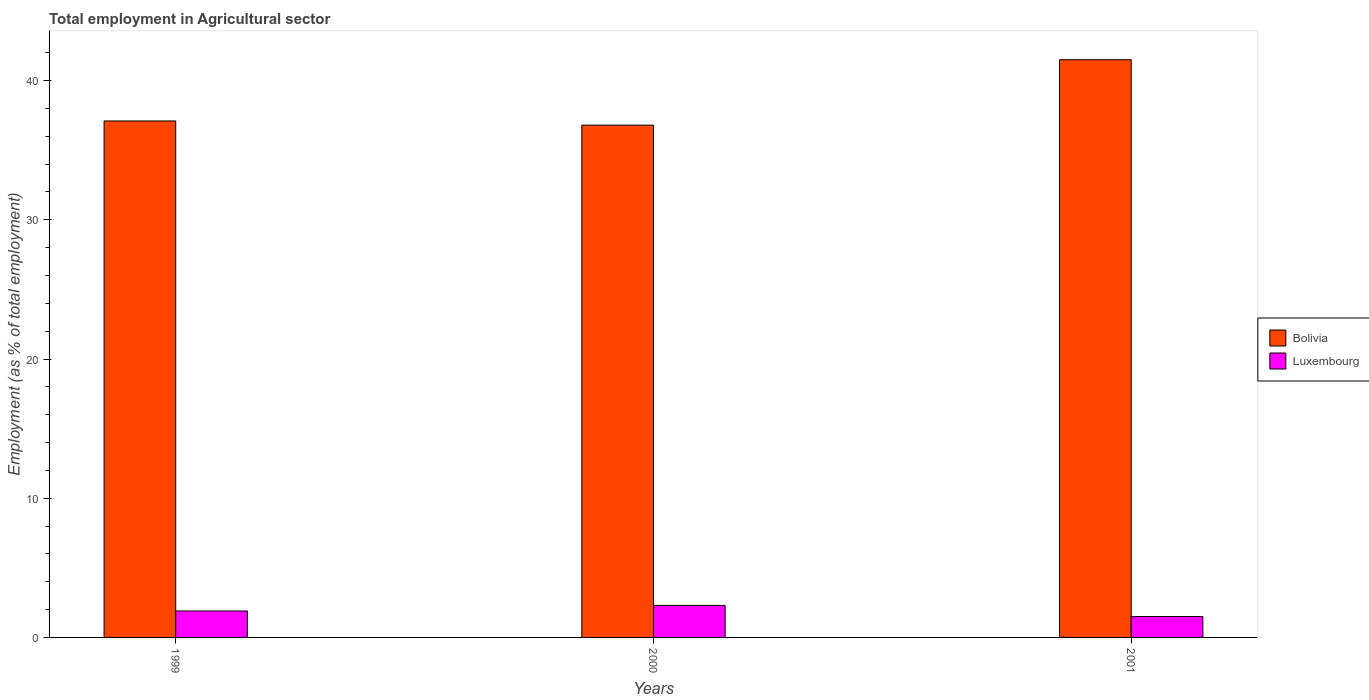How many groups of bars are there?
Your answer should be very brief. 3. Are the number of bars per tick equal to the number of legend labels?
Ensure brevity in your answer.  Yes. Are the number of bars on each tick of the X-axis equal?
Ensure brevity in your answer.  Yes. How many bars are there on the 2nd tick from the left?
Keep it short and to the point. 2. How many bars are there on the 1st tick from the right?
Keep it short and to the point. 2. What is the label of the 1st group of bars from the left?
Your answer should be very brief. 1999. What is the employment in agricultural sector in Bolivia in 1999?
Provide a succinct answer. 37.1. Across all years, what is the maximum employment in agricultural sector in Bolivia?
Provide a succinct answer. 41.5. In which year was the employment in agricultural sector in Luxembourg maximum?
Your response must be concise. 2000. In which year was the employment in agricultural sector in Bolivia minimum?
Provide a succinct answer. 2000. What is the total employment in agricultural sector in Bolivia in the graph?
Ensure brevity in your answer.  115.4. What is the difference between the employment in agricultural sector in Bolivia in 2000 and that in 2001?
Give a very brief answer. -4.7. What is the difference between the employment in agricultural sector in Luxembourg in 2001 and the employment in agricultural sector in Bolivia in 1999?
Keep it short and to the point. -35.6. What is the average employment in agricultural sector in Luxembourg per year?
Offer a very short reply. 1.9. In the year 2000, what is the difference between the employment in agricultural sector in Bolivia and employment in agricultural sector in Luxembourg?
Offer a terse response. 34.5. In how many years, is the employment in agricultural sector in Bolivia greater than 10 %?
Give a very brief answer. 3. What is the ratio of the employment in agricultural sector in Bolivia in 1999 to that in 2000?
Your answer should be very brief. 1.01. What is the difference between the highest and the second highest employment in agricultural sector in Luxembourg?
Ensure brevity in your answer.  0.4. What is the difference between the highest and the lowest employment in agricultural sector in Luxembourg?
Provide a succinct answer. 0.8. In how many years, is the employment in agricultural sector in Luxembourg greater than the average employment in agricultural sector in Luxembourg taken over all years?
Your answer should be compact. 1. What does the 1st bar from the left in 2001 represents?
Offer a terse response. Bolivia. What does the 2nd bar from the right in 1999 represents?
Your response must be concise. Bolivia. How many years are there in the graph?
Your response must be concise. 3. Does the graph contain grids?
Your response must be concise. No. Where does the legend appear in the graph?
Provide a succinct answer. Center right. How are the legend labels stacked?
Keep it short and to the point. Vertical. What is the title of the graph?
Provide a succinct answer. Total employment in Agricultural sector. Does "Least developed countries" appear as one of the legend labels in the graph?
Offer a terse response. No. What is the label or title of the Y-axis?
Your answer should be compact. Employment (as % of total employment). What is the Employment (as % of total employment) of Bolivia in 1999?
Your answer should be compact. 37.1. What is the Employment (as % of total employment) of Luxembourg in 1999?
Provide a short and direct response. 1.9. What is the Employment (as % of total employment) in Bolivia in 2000?
Provide a succinct answer. 36.8. What is the Employment (as % of total employment) in Luxembourg in 2000?
Offer a very short reply. 2.3. What is the Employment (as % of total employment) of Bolivia in 2001?
Ensure brevity in your answer.  41.5. What is the Employment (as % of total employment) in Luxembourg in 2001?
Ensure brevity in your answer.  1.5. Across all years, what is the maximum Employment (as % of total employment) in Bolivia?
Make the answer very short. 41.5. Across all years, what is the maximum Employment (as % of total employment) of Luxembourg?
Keep it short and to the point. 2.3. Across all years, what is the minimum Employment (as % of total employment) of Bolivia?
Offer a terse response. 36.8. Across all years, what is the minimum Employment (as % of total employment) in Luxembourg?
Provide a short and direct response. 1.5. What is the total Employment (as % of total employment) of Bolivia in the graph?
Your response must be concise. 115.4. What is the difference between the Employment (as % of total employment) of Bolivia in 1999 and that in 2000?
Offer a terse response. 0.3. What is the difference between the Employment (as % of total employment) in Luxembourg in 1999 and that in 2000?
Provide a short and direct response. -0.4. What is the difference between the Employment (as % of total employment) of Bolivia in 1999 and the Employment (as % of total employment) of Luxembourg in 2000?
Make the answer very short. 34.8. What is the difference between the Employment (as % of total employment) of Bolivia in 1999 and the Employment (as % of total employment) of Luxembourg in 2001?
Keep it short and to the point. 35.6. What is the difference between the Employment (as % of total employment) of Bolivia in 2000 and the Employment (as % of total employment) of Luxembourg in 2001?
Keep it short and to the point. 35.3. What is the average Employment (as % of total employment) in Bolivia per year?
Provide a short and direct response. 38.47. What is the average Employment (as % of total employment) of Luxembourg per year?
Your answer should be compact. 1.9. In the year 1999, what is the difference between the Employment (as % of total employment) in Bolivia and Employment (as % of total employment) in Luxembourg?
Provide a short and direct response. 35.2. In the year 2000, what is the difference between the Employment (as % of total employment) of Bolivia and Employment (as % of total employment) of Luxembourg?
Ensure brevity in your answer.  34.5. In the year 2001, what is the difference between the Employment (as % of total employment) in Bolivia and Employment (as % of total employment) in Luxembourg?
Offer a very short reply. 40. What is the ratio of the Employment (as % of total employment) of Bolivia in 1999 to that in 2000?
Provide a succinct answer. 1.01. What is the ratio of the Employment (as % of total employment) of Luxembourg in 1999 to that in 2000?
Provide a short and direct response. 0.83. What is the ratio of the Employment (as % of total employment) in Bolivia in 1999 to that in 2001?
Keep it short and to the point. 0.89. What is the ratio of the Employment (as % of total employment) in Luxembourg in 1999 to that in 2001?
Your answer should be very brief. 1.27. What is the ratio of the Employment (as % of total employment) in Bolivia in 2000 to that in 2001?
Give a very brief answer. 0.89. What is the ratio of the Employment (as % of total employment) in Luxembourg in 2000 to that in 2001?
Provide a succinct answer. 1.53. What is the difference between the highest and the second highest Employment (as % of total employment) of Bolivia?
Your answer should be very brief. 4.4. What is the difference between the highest and the lowest Employment (as % of total employment) in Bolivia?
Give a very brief answer. 4.7. 